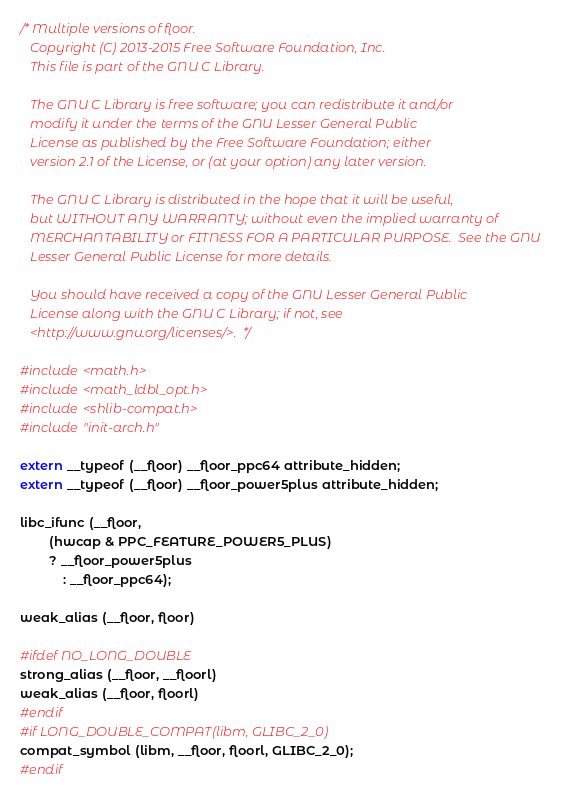<code> <loc_0><loc_0><loc_500><loc_500><_C_>/* Multiple versions of floor.
   Copyright (C) 2013-2015 Free Software Foundation, Inc.
   This file is part of the GNU C Library.

   The GNU C Library is free software; you can redistribute it and/or
   modify it under the terms of the GNU Lesser General Public
   License as published by the Free Software Foundation; either
   version 2.1 of the License, or (at your option) any later version.

   The GNU C Library is distributed in the hope that it will be useful,
   but WITHOUT ANY WARRANTY; without even the implied warranty of
   MERCHANTABILITY or FITNESS FOR A PARTICULAR PURPOSE.  See the GNU
   Lesser General Public License for more details.

   You should have received a copy of the GNU Lesser General Public
   License along with the GNU C Library; if not, see
   <http://www.gnu.org/licenses/>.  */

#include <math.h>
#include <math_ldbl_opt.h>
#include <shlib-compat.h>
#include "init-arch.h"

extern __typeof (__floor) __floor_ppc64 attribute_hidden;
extern __typeof (__floor) __floor_power5plus attribute_hidden;

libc_ifunc (__floor,
	    (hwcap & PPC_FEATURE_POWER5_PLUS)
	    ? __floor_power5plus
            : __floor_ppc64);

weak_alias (__floor, floor)

#ifdef NO_LONG_DOUBLE
strong_alias (__floor, __floorl)
weak_alias (__floor, floorl)
#endif
#if LONG_DOUBLE_COMPAT(libm, GLIBC_2_0)
compat_symbol (libm, __floor, floorl, GLIBC_2_0);
#endif
</code> 